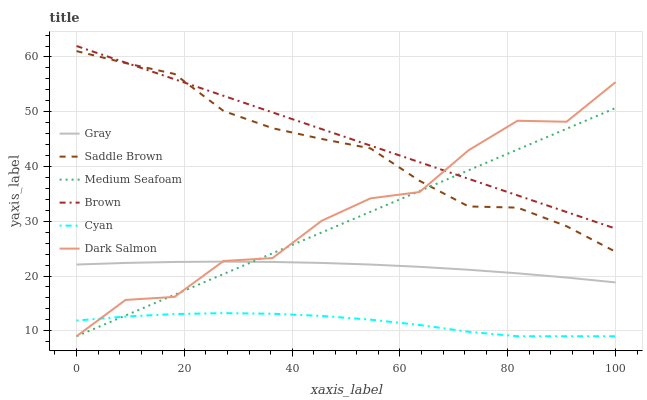Does Cyan have the minimum area under the curve?
Answer yes or no. Yes. Does Brown have the maximum area under the curve?
Answer yes or no. Yes. Does Dark Salmon have the minimum area under the curve?
Answer yes or no. No. Does Dark Salmon have the maximum area under the curve?
Answer yes or no. No. Is Medium Seafoam the smoothest?
Answer yes or no. Yes. Is Dark Salmon the roughest?
Answer yes or no. Yes. Is Brown the smoothest?
Answer yes or no. No. Is Brown the roughest?
Answer yes or no. No. Does Dark Salmon have the lowest value?
Answer yes or no. Yes. Does Brown have the lowest value?
Answer yes or no. No. Does Brown have the highest value?
Answer yes or no. Yes. Does Dark Salmon have the highest value?
Answer yes or no. No. Is Cyan less than Gray?
Answer yes or no. Yes. Is Saddle Brown greater than Cyan?
Answer yes or no. Yes. Does Medium Seafoam intersect Gray?
Answer yes or no. Yes. Is Medium Seafoam less than Gray?
Answer yes or no. No. Is Medium Seafoam greater than Gray?
Answer yes or no. No. Does Cyan intersect Gray?
Answer yes or no. No. 